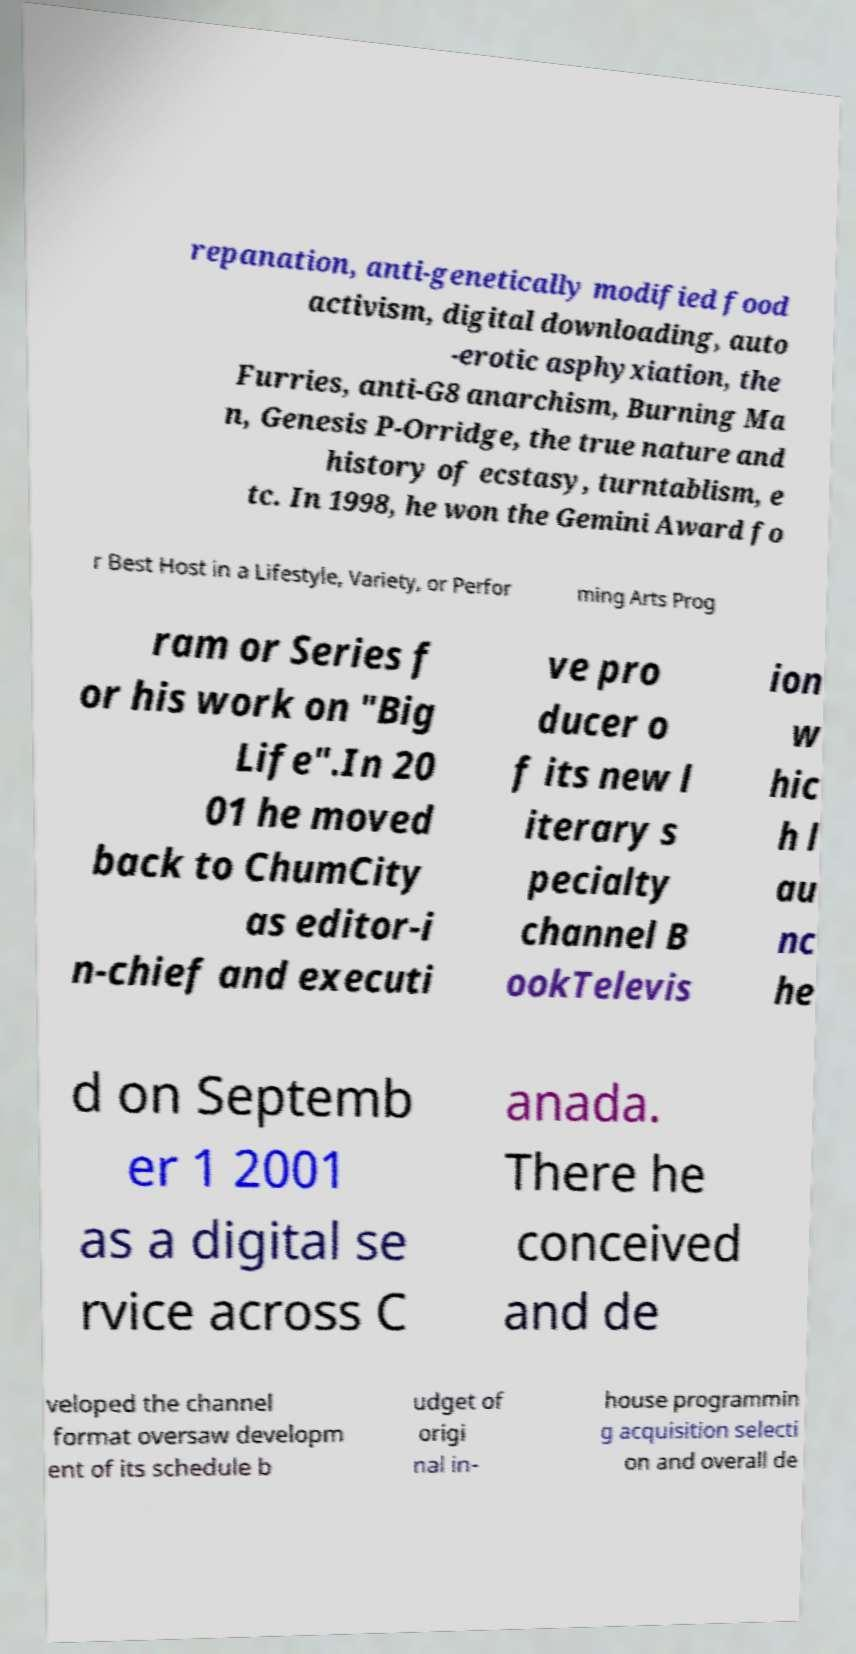Please identify and transcribe the text found in this image. repanation, anti-genetically modified food activism, digital downloading, auto -erotic asphyxiation, the Furries, anti-G8 anarchism, Burning Ma n, Genesis P-Orridge, the true nature and history of ecstasy, turntablism, e tc. In 1998, he won the Gemini Award fo r Best Host in a Lifestyle, Variety, or Perfor ming Arts Prog ram or Series f or his work on "Big Life".In 20 01 he moved back to ChumCity as editor-i n-chief and executi ve pro ducer o f its new l iterary s pecialty channel B ookTelevis ion w hic h l au nc he d on Septemb er 1 2001 as a digital se rvice across C anada. There he conceived and de veloped the channel format oversaw developm ent of its schedule b udget of origi nal in- house programmin g acquisition selecti on and overall de 